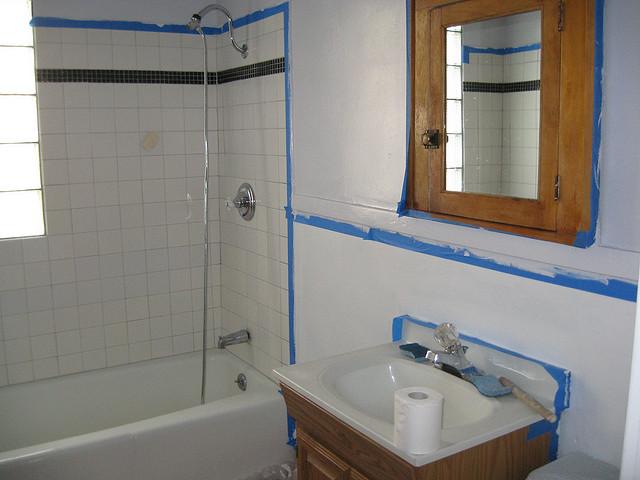What kind of work was just done in the bathroom?
Answer briefly. Painting. Is there any wood in this bathroom?
Quick response, please. Yes. Is the bathroom usable?
Write a very short answer. Yes. What is the purpose of the blue tape?
Keep it brief. To prevent paint from getting on things. What colors are the stripes?
Short answer required. Blue. Is this a residential bathroom?
Write a very short answer. Yes. How many towel racks are there?
Concise answer only. 0. 